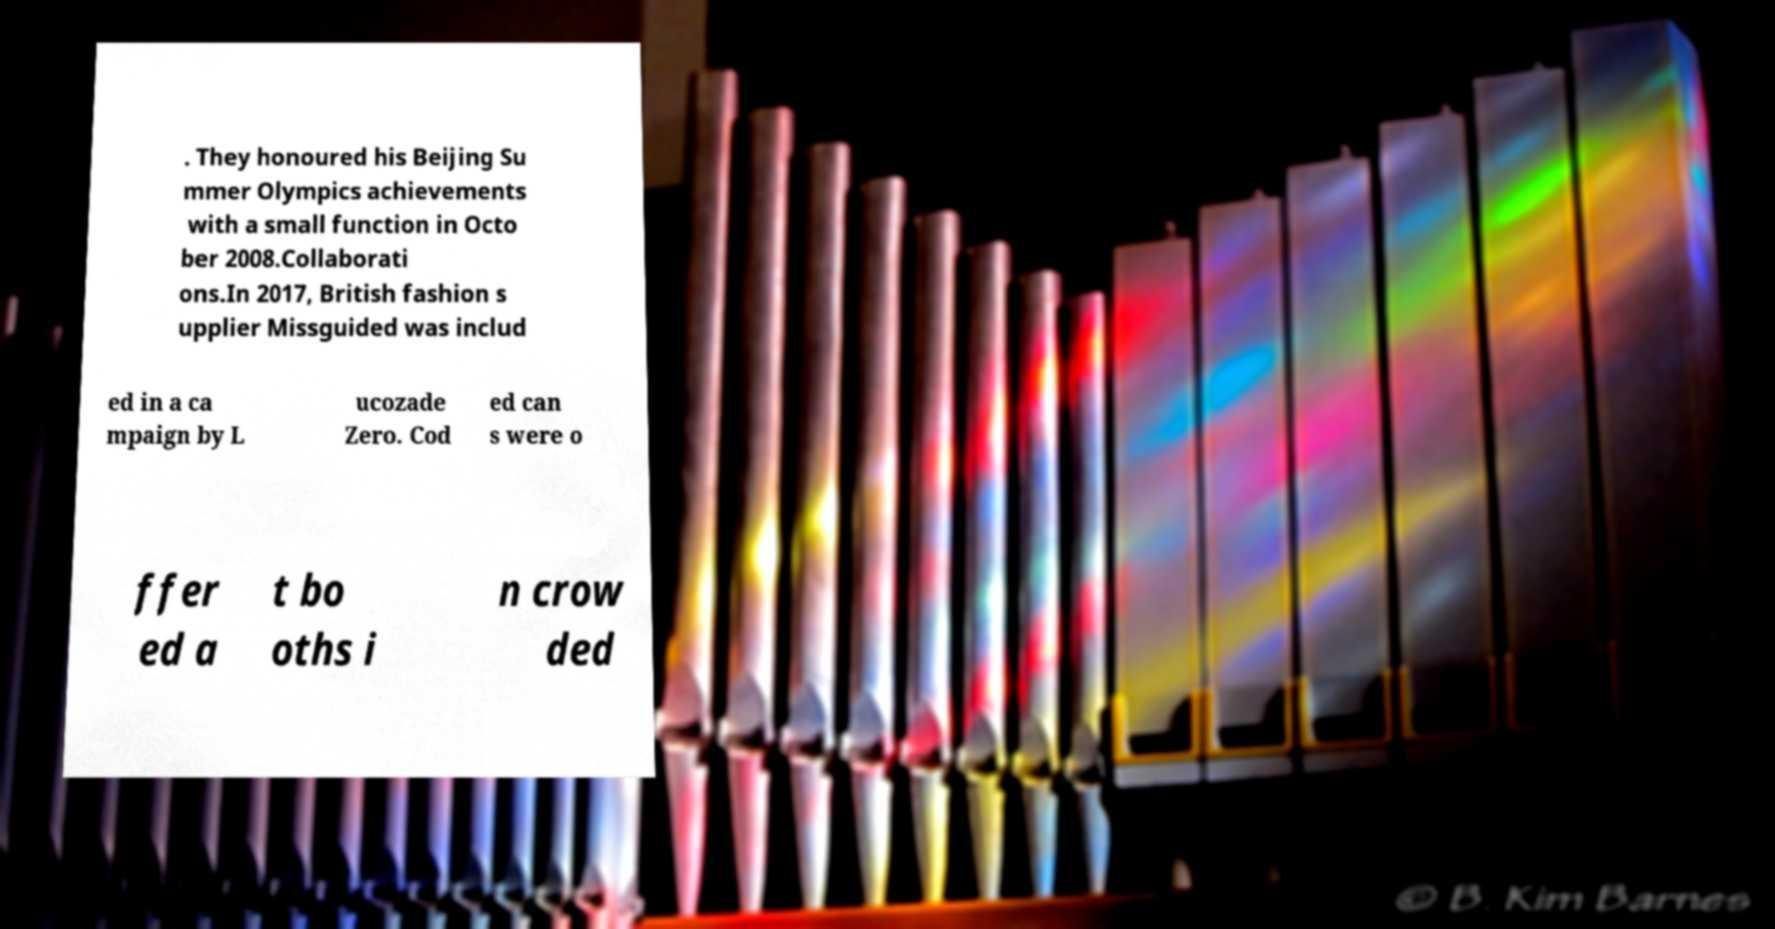There's text embedded in this image that I need extracted. Can you transcribe it verbatim? . They honoured his Beijing Su mmer Olympics achievements with a small function in Octo ber 2008.Collaborati ons.In 2017, British fashion s upplier Missguided was includ ed in a ca mpaign by L ucozade Zero. Cod ed can s were o ffer ed a t bo oths i n crow ded 